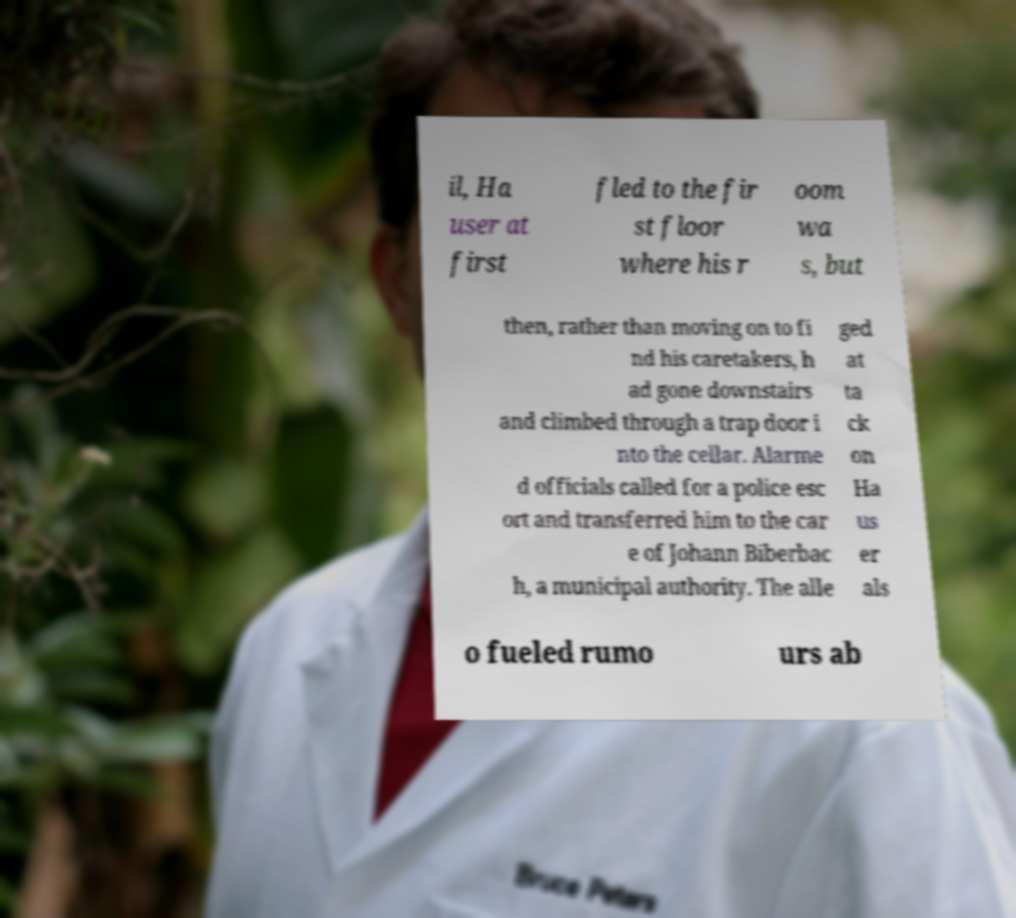For documentation purposes, I need the text within this image transcribed. Could you provide that? il, Ha user at first fled to the fir st floor where his r oom wa s, but then, rather than moving on to fi nd his caretakers, h ad gone downstairs and climbed through a trap door i nto the cellar. Alarme d officials called for a police esc ort and transferred him to the car e of Johann Biberbac h, a municipal authority. The alle ged at ta ck on Ha us er als o fueled rumo urs ab 